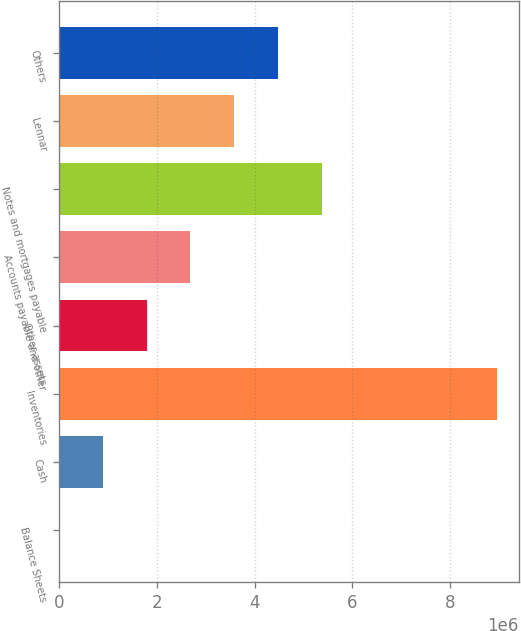Convert chart to OTSL. <chart><loc_0><loc_0><loc_500><loc_500><bar_chart><fcel>Balance Sheets<fcel>Cash<fcel>Inventories<fcel>Other assets<fcel>Accounts payable and other<fcel>Notes and mortgages payable<fcel>Lennar<fcel>Others<nl><fcel>2006<fcel>897362<fcel>8.95557e+06<fcel>1.79272e+06<fcel>2.68807e+06<fcel>5.37414e+06<fcel>3.58343e+06<fcel>4.47879e+06<nl></chart> 